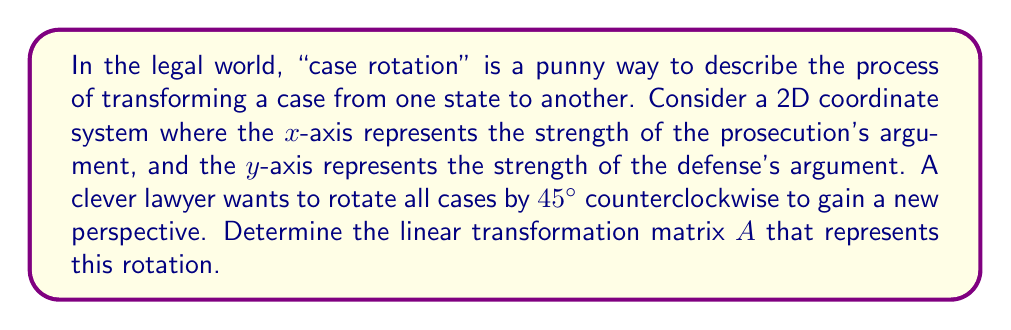Show me your answer to this math problem. To solve this problem, we'll follow these steps:

1) Recall that the general form of a 2D rotation matrix for a counterclockwise rotation by angle $\theta$ is:

   $$A = \begin{bmatrix} 
   \cos\theta & -\sin\theta \\
   \sin\theta & \cos\theta
   \end{bmatrix}$$

2) In this case, $\theta = 45°$. We need to express $\cos 45°$ and $\sin 45°$ in their exact forms:

   $\cos 45° = \sin 45° = \frac{\sqrt{2}}{2}$

3) Substituting these values into the rotation matrix:

   $$A = \begin{bmatrix} 
   \frac{\sqrt{2}}{2} & -\frac{\sqrt{2}}{2} \\
   \frac{\sqrt{2}}{2} & \frac{\sqrt{2}}{2}
   \end{bmatrix}$$

4) This matrix $A$ will rotate any point (or case, in our legal pun context) by 45° counterclockwise around the origin.

To verify, we can apply this transformation to a point on the x-axis, say (1,0):

$$\begin{bmatrix} 
\frac{\sqrt{2}}{2} & -\frac{\sqrt{2}}{2} \\
\frac{\sqrt{2}}{2} & \frac{\sqrt{2}}{2}
\end{bmatrix} \begin{bmatrix} 
1 \\
0
\end{bmatrix} = \begin{bmatrix} 
\frac{\sqrt{2}}{2} \\
\frac{\sqrt{2}}{2}
\end{bmatrix}$$

This result indeed represents the point (1,0) rotated by 45°.
Answer: $$A = \begin{bmatrix} 
\frac{\sqrt{2}}{2} & -\frac{\sqrt{2}}{2} \\
\frac{\sqrt{2}}{2} & \frac{\sqrt{2}}{2}
\end{bmatrix}$$ 